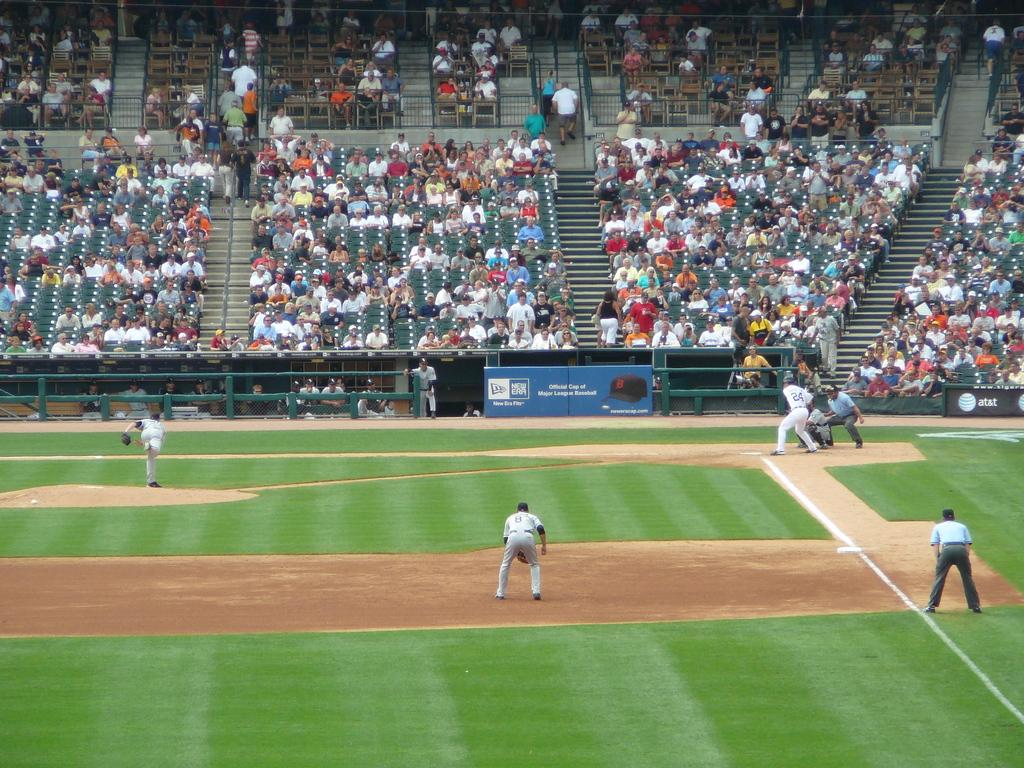What sport are the people playing in the image? The people are playing baseball in the image. Where is the baseball game taking place? The baseball game is taking place in a stadium. Are there any spectators present in the image? Yes, there are people seated in the stadium watching the game. Can you see any cattle grazing in the outfield during the baseball game? There are no cattle present in the image; it features a baseball game taking place in a stadium. 